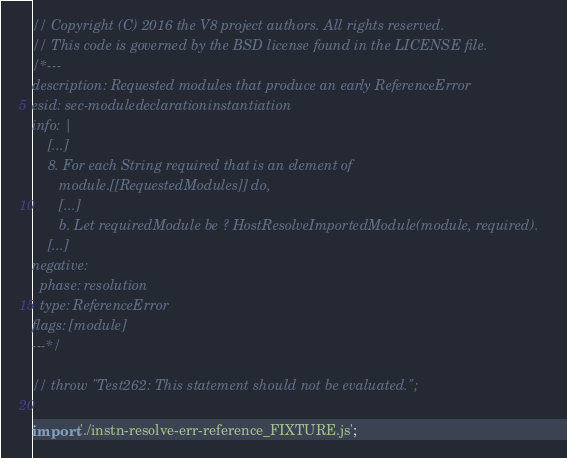Convert code to text. <code><loc_0><loc_0><loc_500><loc_500><_JavaScript_>// Copyright (C) 2016 the V8 project authors. All rights reserved.
// This code is governed by the BSD license found in the LICENSE file.
/*---
description: Requested modules that produce an early ReferenceError
esid: sec-moduledeclarationinstantiation
info: |
    [...]
    8. For each String required that is an element of
       module.[[RequestedModules]] do,
       [...]
       b. Let requiredModule be ? HostResolveImportedModule(module, required).
    [...]
negative:
  phase: resolution
  type: ReferenceError
flags: [module]
---*/

// throw "Test262: This statement should not be evaluated.";

import './instn-resolve-err-reference_FIXTURE.js';
</code> 